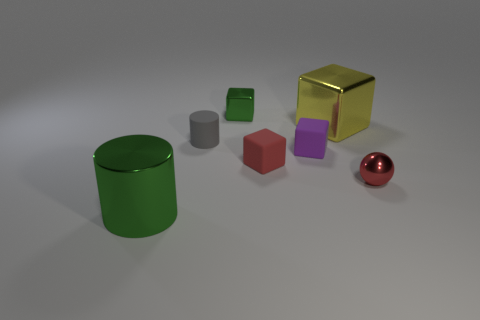What size is the metallic thing that is the same color as the metallic cylinder?
Keep it short and to the point. Small. There is another metallic thing that is the same shape as the gray thing; what is its size?
Give a very brief answer. Large. Is there anything else that is made of the same material as the tiny gray thing?
Your response must be concise. Yes. Are any yellow objects visible?
Give a very brief answer. Yes. Does the shiny sphere have the same color as the metallic object that is on the left side of the green cube?
Your answer should be very brief. No. What size is the green metal object that is in front of the shiny block in front of the green metal object behind the small red metallic ball?
Ensure brevity in your answer.  Large. What number of small blocks have the same color as the tiny metal ball?
Offer a very short reply. 1. What number of objects are either large gray rubber spheres or shiny things that are behind the large green object?
Offer a very short reply. 3. What color is the matte cylinder?
Keep it short and to the point. Gray. There is a cylinder that is behind the tiny purple matte cube; what is its color?
Ensure brevity in your answer.  Gray. 